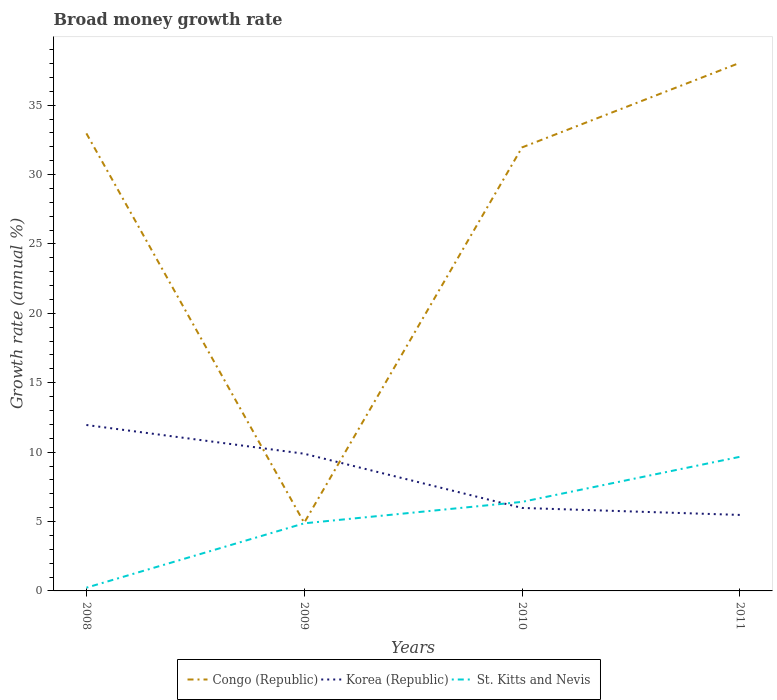How many different coloured lines are there?
Ensure brevity in your answer.  3. Is the number of lines equal to the number of legend labels?
Your response must be concise. Yes. Across all years, what is the maximum growth rate in Congo (Republic)?
Provide a short and direct response. 4.91. In which year was the growth rate in Congo (Republic) maximum?
Your answer should be compact. 2009. What is the total growth rate in St. Kitts and Nevis in the graph?
Your answer should be compact. -3.25. What is the difference between the highest and the second highest growth rate in Korea (Republic)?
Give a very brief answer. 6.48. What is the difference between the highest and the lowest growth rate in St. Kitts and Nevis?
Your response must be concise. 2. How many lines are there?
Offer a terse response. 3. What is the difference between two consecutive major ticks on the Y-axis?
Provide a short and direct response. 5. Does the graph contain any zero values?
Your response must be concise. No. Where does the legend appear in the graph?
Your response must be concise. Bottom center. How many legend labels are there?
Make the answer very short. 3. How are the legend labels stacked?
Your answer should be compact. Horizontal. What is the title of the graph?
Provide a short and direct response. Broad money growth rate. What is the label or title of the X-axis?
Give a very brief answer. Years. What is the label or title of the Y-axis?
Provide a succinct answer. Growth rate (annual %). What is the Growth rate (annual %) in Congo (Republic) in 2008?
Ensure brevity in your answer.  32.97. What is the Growth rate (annual %) of Korea (Republic) in 2008?
Provide a short and direct response. 11.96. What is the Growth rate (annual %) of St. Kitts and Nevis in 2008?
Provide a short and direct response. 0.23. What is the Growth rate (annual %) of Congo (Republic) in 2009?
Provide a short and direct response. 4.91. What is the Growth rate (annual %) of Korea (Republic) in 2009?
Offer a terse response. 9.89. What is the Growth rate (annual %) of St. Kitts and Nevis in 2009?
Provide a succinct answer. 4.87. What is the Growth rate (annual %) of Congo (Republic) in 2010?
Give a very brief answer. 31.96. What is the Growth rate (annual %) in Korea (Republic) in 2010?
Your answer should be very brief. 5.98. What is the Growth rate (annual %) of St. Kitts and Nevis in 2010?
Provide a short and direct response. 6.41. What is the Growth rate (annual %) in Congo (Republic) in 2011?
Your response must be concise. 38.05. What is the Growth rate (annual %) in Korea (Republic) in 2011?
Keep it short and to the point. 5.48. What is the Growth rate (annual %) of St. Kitts and Nevis in 2011?
Keep it short and to the point. 9.66. Across all years, what is the maximum Growth rate (annual %) in Congo (Republic)?
Ensure brevity in your answer.  38.05. Across all years, what is the maximum Growth rate (annual %) of Korea (Republic)?
Make the answer very short. 11.96. Across all years, what is the maximum Growth rate (annual %) in St. Kitts and Nevis?
Provide a short and direct response. 9.66. Across all years, what is the minimum Growth rate (annual %) of Congo (Republic)?
Offer a very short reply. 4.91. Across all years, what is the minimum Growth rate (annual %) in Korea (Republic)?
Give a very brief answer. 5.48. Across all years, what is the minimum Growth rate (annual %) of St. Kitts and Nevis?
Make the answer very short. 0.23. What is the total Growth rate (annual %) in Congo (Republic) in the graph?
Provide a succinct answer. 107.89. What is the total Growth rate (annual %) in Korea (Republic) in the graph?
Keep it short and to the point. 33.3. What is the total Growth rate (annual %) of St. Kitts and Nevis in the graph?
Offer a terse response. 21.18. What is the difference between the Growth rate (annual %) of Congo (Republic) in 2008 and that in 2009?
Provide a succinct answer. 28.06. What is the difference between the Growth rate (annual %) of Korea (Republic) in 2008 and that in 2009?
Your answer should be compact. 2.07. What is the difference between the Growth rate (annual %) in St. Kitts and Nevis in 2008 and that in 2009?
Provide a short and direct response. -4.64. What is the difference between the Growth rate (annual %) of Congo (Republic) in 2008 and that in 2010?
Make the answer very short. 1.01. What is the difference between the Growth rate (annual %) in Korea (Republic) in 2008 and that in 2010?
Ensure brevity in your answer.  5.98. What is the difference between the Growth rate (annual %) in St. Kitts and Nevis in 2008 and that in 2010?
Your response must be concise. -6.18. What is the difference between the Growth rate (annual %) of Congo (Republic) in 2008 and that in 2011?
Make the answer very short. -5.08. What is the difference between the Growth rate (annual %) of Korea (Republic) in 2008 and that in 2011?
Your answer should be compact. 6.48. What is the difference between the Growth rate (annual %) of St. Kitts and Nevis in 2008 and that in 2011?
Keep it short and to the point. -9.43. What is the difference between the Growth rate (annual %) in Congo (Republic) in 2009 and that in 2010?
Provide a short and direct response. -27.05. What is the difference between the Growth rate (annual %) in Korea (Republic) in 2009 and that in 2010?
Give a very brief answer. 3.91. What is the difference between the Growth rate (annual %) of St. Kitts and Nevis in 2009 and that in 2010?
Provide a short and direct response. -1.54. What is the difference between the Growth rate (annual %) of Congo (Republic) in 2009 and that in 2011?
Keep it short and to the point. -33.14. What is the difference between the Growth rate (annual %) in Korea (Republic) in 2009 and that in 2011?
Keep it short and to the point. 4.41. What is the difference between the Growth rate (annual %) in St. Kitts and Nevis in 2009 and that in 2011?
Offer a terse response. -4.79. What is the difference between the Growth rate (annual %) of Congo (Republic) in 2010 and that in 2011?
Your answer should be compact. -6.1. What is the difference between the Growth rate (annual %) in Korea (Republic) in 2010 and that in 2011?
Your answer should be very brief. 0.5. What is the difference between the Growth rate (annual %) of St. Kitts and Nevis in 2010 and that in 2011?
Provide a short and direct response. -3.25. What is the difference between the Growth rate (annual %) of Congo (Republic) in 2008 and the Growth rate (annual %) of Korea (Republic) in 2009?
Offer a very short reply. 23.08. What is the difference between the Growth rate (annual %) of Congo (Republic) in 2008 and the Growth rate (annual %) of St. Kitts and Nevis in 2009?
Give a very brief answer. 28.1. What is the difference between the Growth rate (annual %) in Korea (Republic) in 2008 and the Growth rate (annual %) in St. Kitts and Nevis in 2009?
Your answer should be very brief. 7.09. What is the difference between the Growth rate (annual %) of Congo (Republic) in 2008 and the Growth rate (annual %) of Korea (Republic) in 2010?
Keep it short and to the point. 26.99. What is the difference between the Growth rate (annual %) of Congo (Republic) in 2008 and the Growth rate (annual %) of St. Kitts and Nevis in 2010?
Provide a short and direct response. 26.55. What is the difference between the Growth rate (annual %) of Korea (Republic) in 2008 and the Growth rate (annual %) of St. Kitts and Nevis in 2010?
Offer a very short reply. 5.54. What is the difference between the Growth rate (annual %) of Congo (Republic) in 2008 and the Growth rate (annual %) of Korea (Republic) in 2011?
Provide a succinct answer. 27.49. What is the difference between the Growth rate (annual %) of Congo (Republic) in 2008 and the Growth rate (annual %) of St. Kitts and Nevis in 2011?
Make the answer very short. 23.31. What is the difference between the Growth rate (annual %) of Korea (Republic) in 2008 and the Growth rate (annual %) of St. Kitts and Nevis in 2011?
Your response must be concise. 2.29. What is the difference between the Growth rate (annual %) in Congo (Republic) in 2009 and the Growth rate (annual %) in Korea (Republic) in 2010?
Ensure brevity in your answer.  -1.07. What is the difference between the Growth rate (annual %) in Congo (Republic) in 2009 and the Growth rate (annual %) in St. Kitts and Nevis in 2010?
Provide a short and direct response. -1.51. What is the difference between the Growth rate (annual %) in Korea (Republic) in 2009 and the Growth rate (annual %) in St. Kitts and Nevis in 2010?
Offer a terse response. 3.47. What is the difference between the Growth rate (annual %) in Congo (Republic) in 2009 and the Growth rate (annual %) in Korea (Republic) in 2011?
Keep it short and to the point. -0.57. What is the difference between the Growth rate (annual %) of Congo (Republic) in 2009 and the Growth rate (annual %) of St. Kitts and Nevis in 2011?
Provide a short and direct response. -4.75. What is the difference between the Growth rate (annual %) in Korea (Republic) in 2009 and the Growth rate (annual %) in St. Kitts and Nevis in 2011?
Give a very brief answer. 0.22. What is the difference between the Growth rate (annual %) in Congo (Republic) in 2010 and the Growth rate (annual %) in Korea (Republic) in 2011?
Offer a very short reply. 26.48. What is the difference between the Growth rate (annual %) of Congo (Republic) in 2010 and the Growth rate (annual %) of St. Kitts and Nevis in 2011?
Ensure brevity in your answer.  22.29. What is the difference between the Growth rate (annual %) of Korea (Republic) in 2010 and the Growth rate (annual %) of St. Kitts and Nevis in 2011?
Make the answer very short. -3.68. What is the average Growth rate (annual %) of Congo (Republic) per year?
Offer a terse response. 26.97. What is the average Growth rate (annual %) of Korea (Republic) per year?
Make the answer very short. 8.32. What is the average Growth rate (annual %) of St. Kitts and Nevis per year?
Give a very brief answer. 5.3. In the year 2008, what is the difference between the Growth rate (annual %) in Congo (Republic) and Growth rate (annual %) in Korea (Republic)?
Give a very brief answer. 21.01. In the year 2008, what is the difference between the Growth rate (annual %) of Congo (Republic) and Growth rate (annual %) of St. Kitts and Nevis?
Keep it short and to the point. 32.74. In the year 2008, what is the difference between the Growth rate (annual %) of Korea (Republic) and Growth rate (annual %) of St. Kitts and Nevis?
Make the answer very short. 11.72. In the year 2009, what is the difference between the Growth rate (annual %) of Congo (Republic) and Growth rate (annual %) of Korea (Republic)?
Offer a very short reply. -4.98. In the year 2009, what is the difference between the Growth rate (annual %) of Congo (Republic) and Growth rate (annual %) of St. Kitts and Nevis?
Ensure brevity in your answer.  0.04. In the year 2009, what is the difference between the Growth rate (annual %) in Korea (Republic) and Growth rate (annual %) in St. Kitts and Nevis?
Offer a very short reply. 5.02. In the year 2010, what is the difference between the Growth rate (annual %) in Congo (Republic) and Growth rate (annual %) in Korea (Republic)?
Offer a terse response. 25.98. In the year 2010, what is the difference between the Growth rate (annual %) of Congo (Republic) and Growth rate (annual %) of St. Kitts and Nevis?
Provide a short and direct response. 25.54. In the year 2010, what is the difference between the Growth rate (annual %) in Korea (Republic) and Growth rate (annual %) in St. Kitts and Nevis?
Make the answer very short. -0.44. In the year 2011, what is the difference between the Growth rate (annual %) of Congo (Republic) and Growth rate (annual %) of Korea (Republic)?
Provide a short and direct response. 32.58. In the year 2011, what is the difference between the Growth rate (annual %) in Congo (Republic) and Growth rate (annual %) in St. Kitts and Nevis?
Ensure brevity in your answer.  28.39. In the year 2011, what is the difference between the Growth rate (annual %) of Korea (Republic) and Growth rate (annual %) of St. Kitts and Nevis?
Your response must be concise. -4.19. What is the ratio of the Growth rate (annual %) of Congo (Republic) in 2008 to that in 2009?
Your answer should be compact. 6.72. What is the ratio of the Growth rate (annual %) in Korea (Republic) in 2008 to that in 2009?
Your answer should be compact. 1.21. What is the ratio of the Growth rate (annual %) of St. Kitts and Nevis in 2008 to that in 2009?
Ensure brevity in your answer.  0.05. What is the ratio of the Growth rate (annual %) of Congo (Republic) in 2008 to that in 2010?
Give a very brief answer. 1.03. What is the ratio of the Growth rate (annual %) of Korea (Republic) in 2008 to that in 2010?
Keep it short and to the point. 2. What is the ratio of the Growth rate (annual %) of St. Kitts and Nevis in 2008 to that in 2010?
Your answer should be very brief. 0.04. What is the ratio of the Growth rate (annual %) of Congo (Republic) in 2008 to that in 2011?
Give a very brief answer. 0.87. What is the ratio of the Growth rate (annual %) of Korea (Republic) in 2008 to that in 2011?
Keep it short and to the point. 2.18. What is the ratio of the Growth rate (annual %) of St. Kitts and Nevis in 2008 to that in 2011?
Keep it short and to the point. 0.02. What is the ratio of the Growth rate (annual %) of Congo (Republic) in 2009 to that in 2010?
Provide a succinct answer. 0.15. What is the ratio of the Growth rate (annual %) in Korea (Republic) in 2009 to that in 2010?
Ensure brevity in your answer.  1.65. What is the ratio of the Growth rate (annual %) in St. Kitts and Nevis in 2009 to that in 2010?
Give a very brief answer. 0.76. What is the ratio of the Growth rate (annual %) of Congo (Republic) in 2009 to that in 2011?
Provide a short and direct response. 0.13. What is the ratio of the Growth rate (annual %) of Korea (Republic) in 2009 to that in 2011?
Offer a terse response. 1.81. What is the ratio of the Growth rate (annual %) in St. Kitts and Nevis in 2009 to that in 2011?
Offer a terse response. 0.5. What is the ratio of the Growth rate (annual %) of Congo (Republic) in 2010 to that in 2011?
Your response must be concise. 0.84. What is the ratio of the Growth rate (annual %) in Korea (Republic) in 2010 to that in 2011?
Your answer should be very brief. 1.09. What is the ratio of the Growth rate (annual %) of St. Kitts and Nevis in 2010 to that in 2011?
Give a very brief answer. 0.66. What is the difference between the highest and the second highest Growth rate (annual %) in Congo (Republic)?
Make the answer very short. 5.08. What is the difference between the highest and the second highest Growth rate (annual %) in Korea (Republic)?
Keep it short and to the point. 2.07. What is the difference between the highest and the second highest Growth rate (annual %) of St. Kitts and Nevis?
Give a very brief answer. 3.25. What is the difference between the highest and the lowest Growth rate (annual %) of Congo (Republic)?
Your answer should be very brief. 33.14. What is the difference between the highest and the lowest Growth rate (annual %) in Korea (Republic)?
Your answer should be very brief. 6.48. What is the difference between the highest and the lowest Growth rate (annual %) of St. Kitts and Nevis?
Keep it short and to the point. 9.43. 